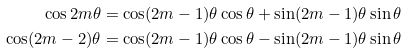Convert formula to latex. <formula><loc_0><loc_0><loc_500><loc_500>\cos 2 m \theta & = \cos ( 2 m - 1 ) \theta \cos \theta + \sin ( 2 m - 1 ) \theta \sin \theta \\ \cos ( 2 m - 2 ) \theta & = \cos ( 2 m - 1 ) \theta \cos \theta - \sin ( 2 m - 1 ) \theta \sin \theta</formula> 